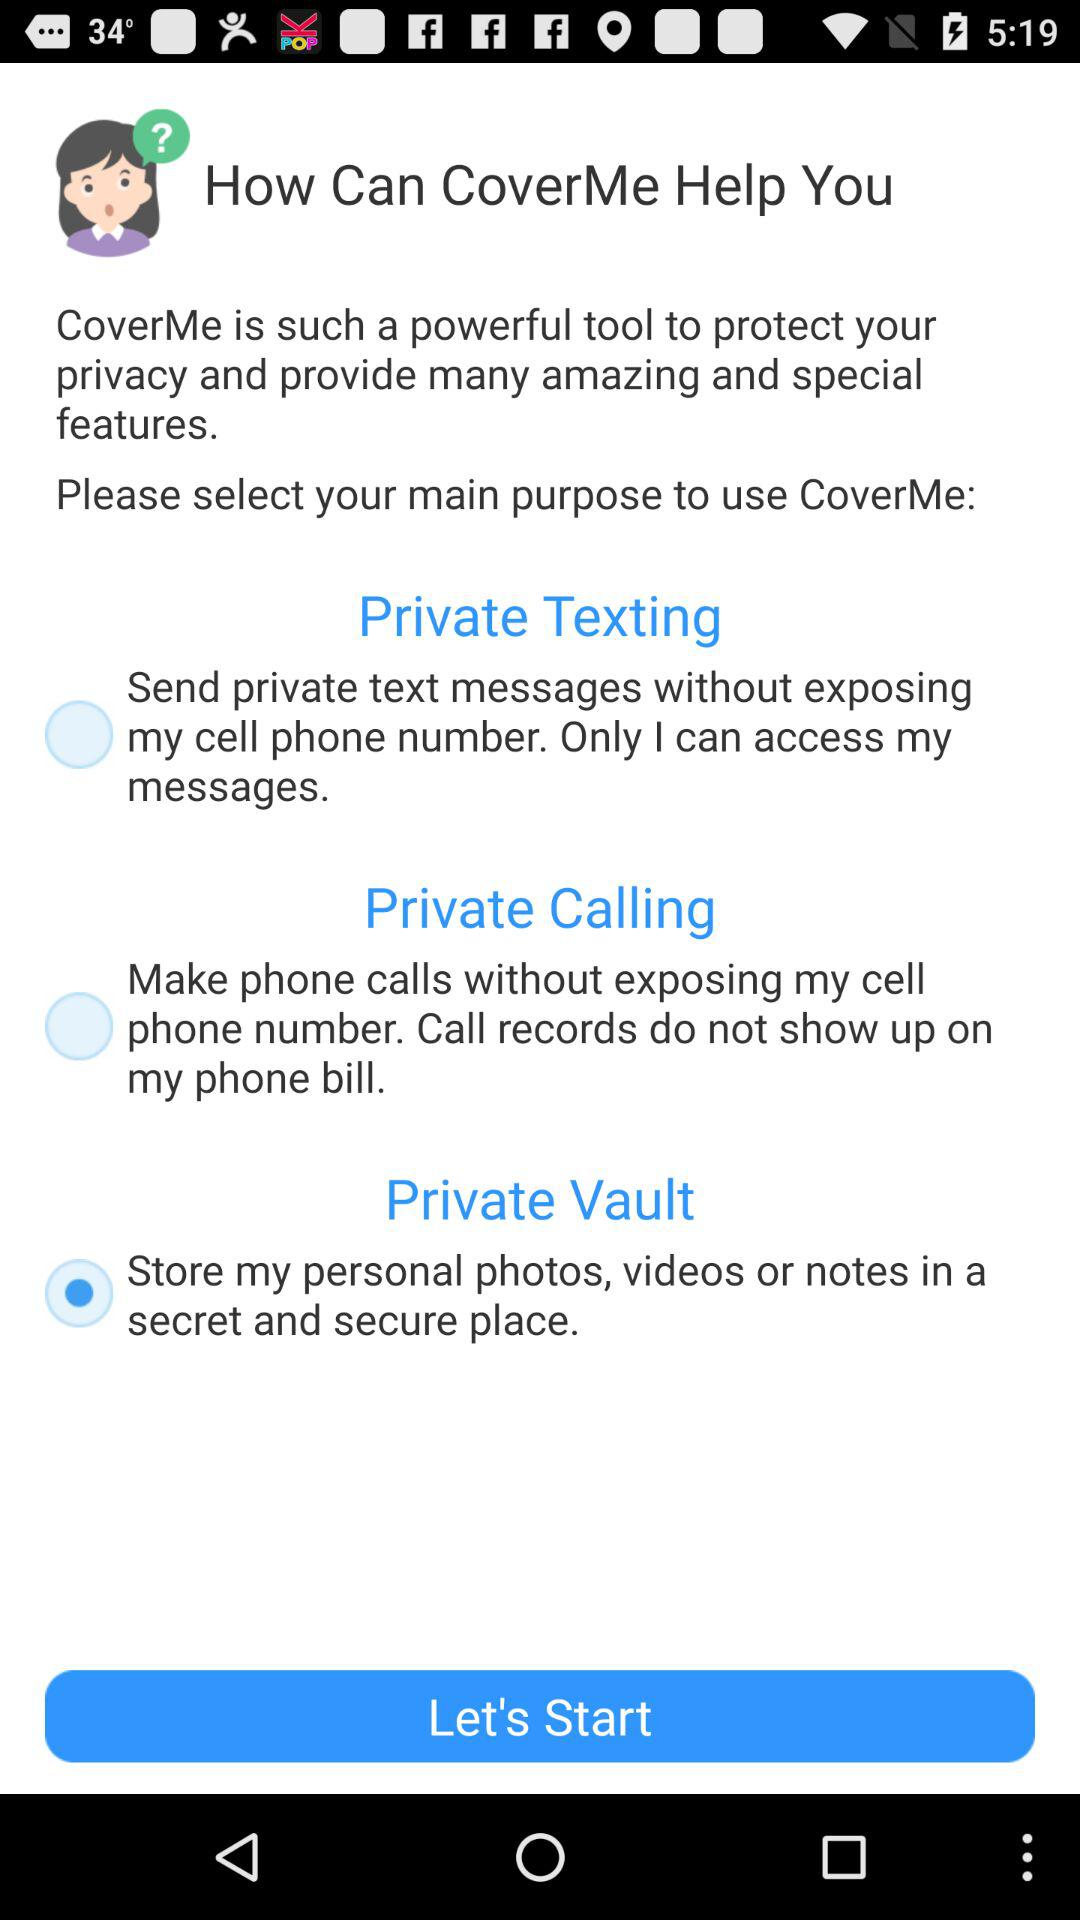What is CoverMe? CoverMe is such a powerful tool to protect your privacy and provide many amazing and special features. 